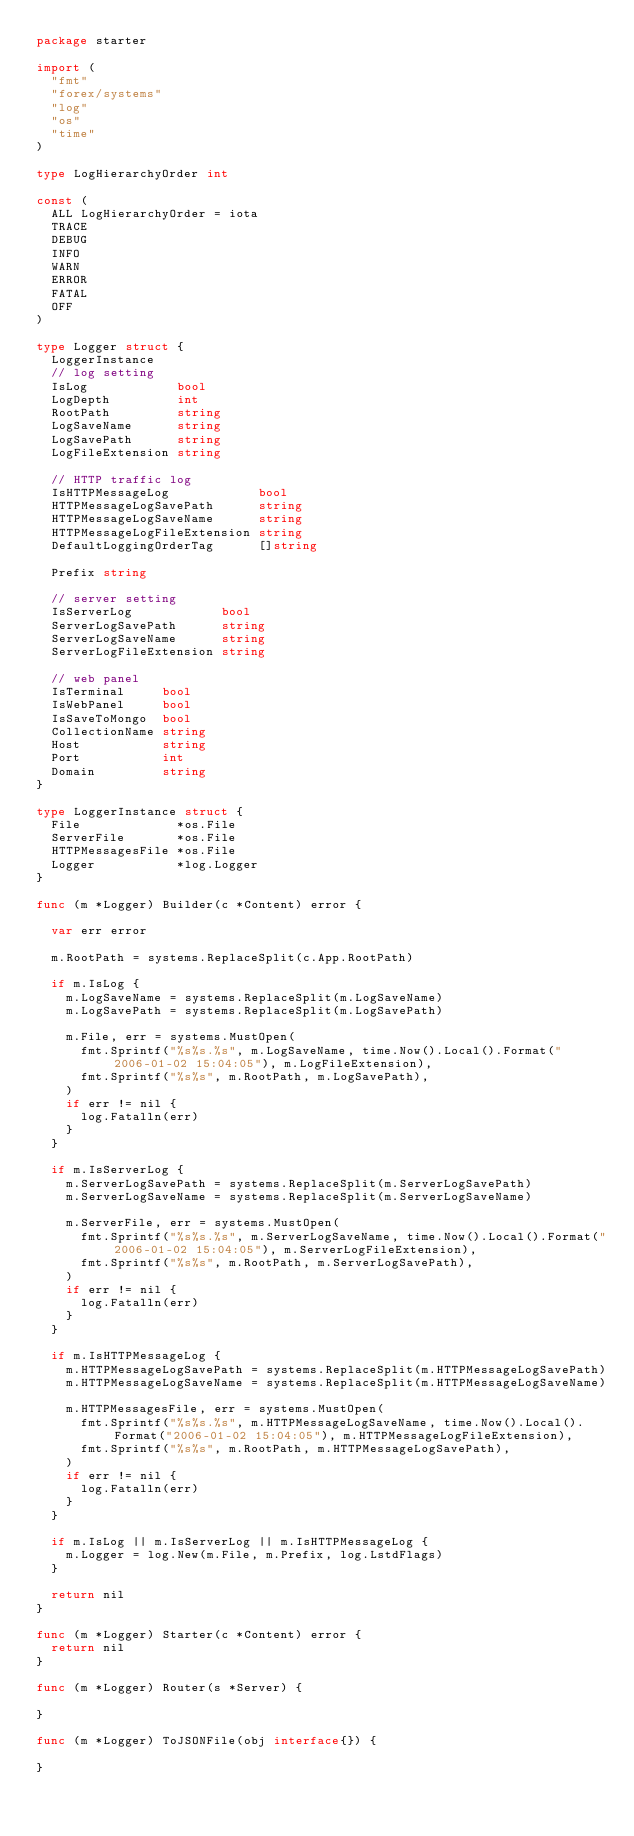<code> <loc_0><loc_0><loc_500><loc_500><_Go_>package starter

import (
	"fmt"
	"forex/systems"
	"log"
	"os"
	"time"
)

type LogHierarchyOrder int

const (
	ALL LogHierarchyOrder = iota
	TRACE
	DEBUG
	INFO
	WARN
	ERROR
	FATAL
	OFF
)

type Logger struct {
	LoggerInstance
	// log setting
	IsLog            bool
	LogDepth         int
	RootPath         string
	LogSaveName      string
	LogSavePath      string
	LogFileExtension string

	// HTTP traffic log
	IsHTTPMessageLog            bool
	HTTPMessageLogSavePath      string
	HTTPMessageLogSaveName      string
	HTTPMessageLogFileExtension string
	DefaultLoggingOrderTag      []string

	Prefix string

	// server setting
	IsServerLog            bool
	ServerLogSavePath      string
	ServerLogSaveName      string
	ServerLogFileExtension string

	// web panel
	IsTerminal     bool
	IsWebPanel     bool
	IsSaveToMongo  bool
	CollectionName string
	Host           string
	Port           int
	Domain         string
}

type LoggerInstance struct {
	File             *os.File
	ServerFile       *os.File
	HTTPMessagesFile *os.File
	Logger           *log.Logger
}

func (m *Logger) Builder(c *Content) error {

	var err error

	m.RootPath = systems.ReplaceSplit(c.App.RootPath)

	if m.IsLog {
		m.LogSaveName = systems.ReplaceSplit(m.LogSaveName)
		m.LogSavePath = systems.ReplaceSplit(m.LogSavePath)

		m.File, err = systems.MustOpen(
			fmt.Sprintf("%s%s.%s", m.LogSaveName, time.Now().Local().Format("2006-01-02 15:04:05"), m.LogFileExtension),
			fmt.Sprintf("%s%s", m.RootPath, m.LogSavePath),
		)
		if err != nil {
			log.Fatalln(err)
		}
	}

	if m.IsServerLog {
		m.ServerLogSavePath = systems.ReplaceSplit(m.ServerLogSavePath)
		m.ServerLogSaveName = systems.ReplaceSplit(m.ServerLogSaveName)

		m.ServerFile, err = systems.MustOpen(
			fmt.Sprintf("%s%s.%s", m.ServerLogSaveName, time.Now().Local().Format("2006-01-02 15:04:05"), m.ServerLogFileExtension),
			fmt.Sprintf("%s%s", m.RootPath, m.ServerLogSavePath),
		)
		if err != nil {
			log.Fatalln(err)
		}
	}

	if m.IsHTTPMessageLog {
		m.HTTPMessageLogSavePath = systems.ReplaceSplit(m.HTTPMessageLogSavePath)
		m.HTTPMessageLogSaveName = systems.ReplaceSplit(m.HTTPMessageLogSaveName)

		m.HTTPMessagesFile, err = systems.MustOpen(
			fmt.Sprintf("%s%s.%s", m.HTTPMessageLogSaveName, time.Now().Local().Format("2006-01-02 15:04:05"), m.HTTPMessageLogFileExtension),
			fmt.Sprintf("%s%s", m.RootPath, m.HTTPMessageLogSavePath),
		)
		if err != nil {
			log.Fatalln(err)
		}
	}

	if m.IsLog || m.IsServerLog || m.IsHTTPMessageLog {
		m.Logger = log.New(m.File, m.Prefix, log.LstdFlags)
	}

	return nil
}

func (m *Logger) Starter(c *Content) error {
	return nil
}

func (m *Logger) Router(s *Server) {

}

func (m *Logger) ToJSONFile(obj interface{}) {
	
}
</code> 